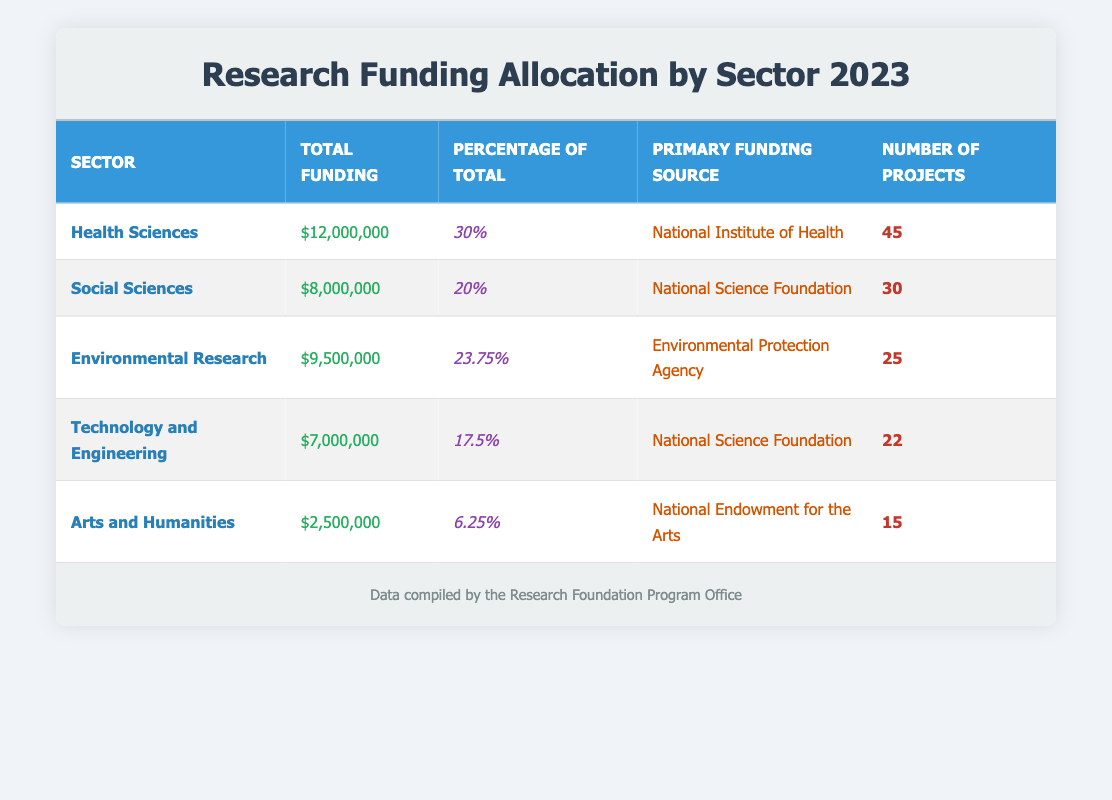What is the total funding for the Health Sciences sector? The table shows that the Health Sciences sector has a total funding of 12,000,000.
Answer: 12,000,000 Which sector has the lowest total funding? The Arts and Humanities sector has the lowest total funding, which is 2,500,000.
Answer: Arts and Humanities What percentage of the total funding is allocated to Environmental Research? The table indicates that Environmental Research receives 23.75% of the total funding.
Answer: 23.75% How many projects are funded by the National Science Foundation? The Social Sciences sector has 30 projects and the Technology and Engineering sector has 22 projects, totaling 52 projects funded by the National Science Foundation.
Answer: 52 Is the primary funding source for Arts and Humanities the National Endowment for the Arts? Yes, the table states that the primary funding source for the Arts and Humanities sector is indeed the National Endowment for the Arts.
Answer: Yes What is the average total funding across all sectors? To find the average, sum up the total funding for all sectors: 12,000,000 + 8,000,000 + 9,500,000 + 7,000,000 + 2,500,000 = 39,000,000. Since there are 5 sectors, divide by 5: 39,000,000 / 5 = 7,800,000.
Answer: 7,800,000 Which sector has a higher number of projects, Environmental Research or Technology and Engineering? Environmental Research has 25 projects while Technology and Engineering has 22 projects. Since 25 is greater than 22, Environmental Research has more projects.
Answer: Environmental Research What is the difference in total funding between Health Sciences and Social Sciences? Health Sciences has 12,000,000, while Social Sciences has 8,000,000. The difference between these two amounts is 12,000,000 - 8,000,000 = 4,000,000.
Answer: 4,000,000 Are there more total funding amounts over 10 million compared to those under 10 million? There is one sector (Health Sciences) with over 10 million and four sectors (Social Sciences, Environmental Research, Technology and Engineering, Arts and Humanities) below that amount. Therefore, there are fewer sectors over 10 million.
Answer: No 